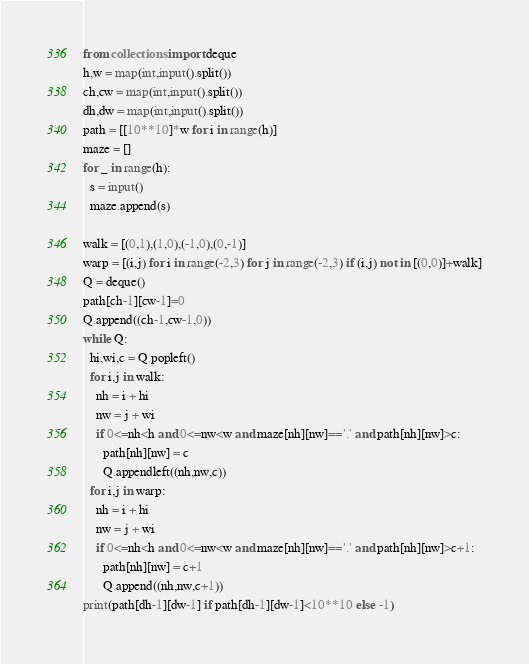Convert code to text. <code><loc_0><loc_0><loc_500><loc_500><_Python_>from collections import deque
h,w = map(int,input().split())
ch,cw = map(int,input().split())
dh,dw = map(int,input().split())
path = [[10**10]*w for i in range(h)]
maze = []
for _ in range(h):
  s = input()
  maze.append(s)

walk = [(0,1),(1,0),(-1,0),(0,-1)]
warp = [(i,j) for i in range(-2,3) for j in range(-2,3) if (i,j) not in [(0,0)]+walk]
Q = deque()
path[ch-1][cw-1]=0
Q.append((ch-1,cw-1,0))
while Q:
  hi,wi,c = Q.popleft()
  for i,j in walk:
    nh = i + hi
    nw = j + wi
    if 0<=nh<h and 0<=nw<w and maze[nh][nw]=='.' and path[nh][nw]>c:
      path[nh][nw] = c
      Q.appendleft((nh,nw,c))
  for i,j in warp:
    nh = i + hi
    nw = j + wi
    if 0<=nh<h and 0<=nw<w and maze[nh][nw]=='.' and path[nh][nw]>c+1:
      path[nh][nw] = c+1
      Q.append((nh,nw,c+1))
print(path[dh-1][dw-1] if path[dh-1][dw-1]<10**10 else -1)</code> 